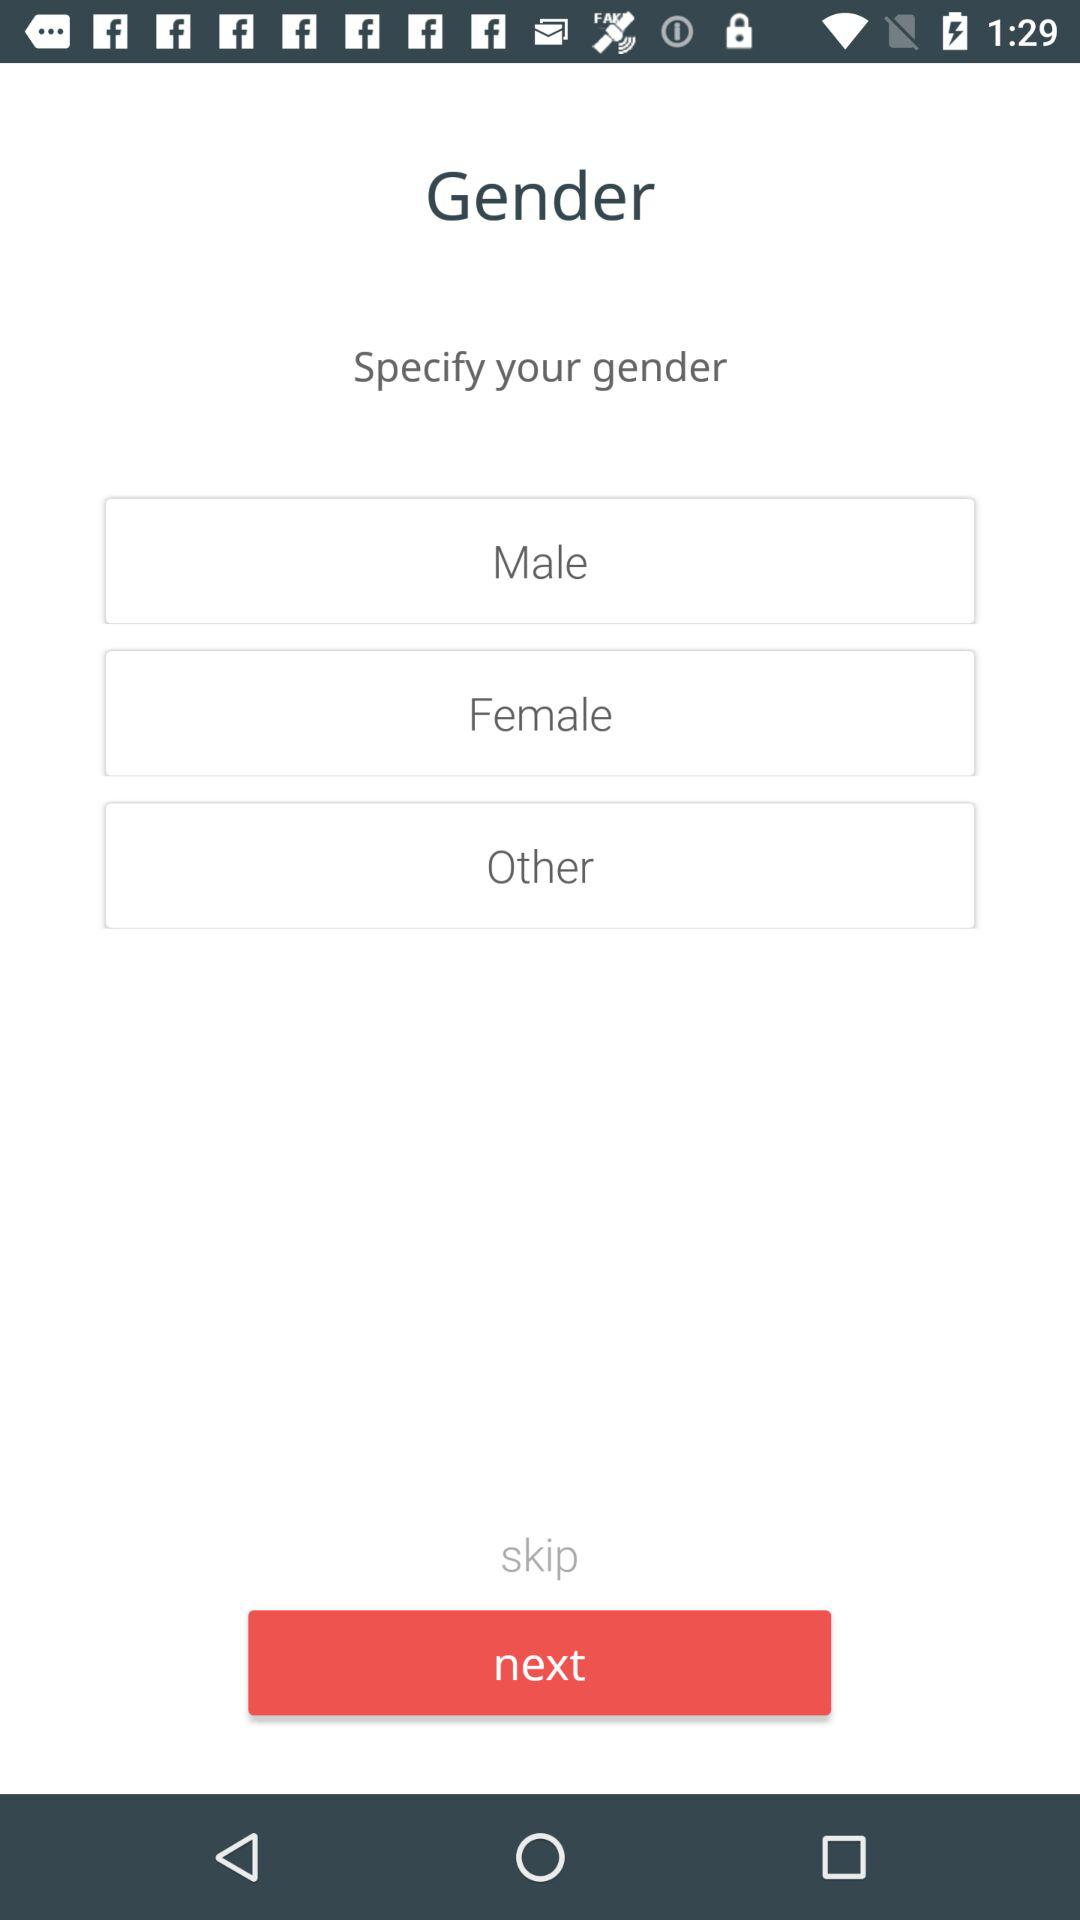Which gender is selected?
When the provided information is insufficient, respond with <no answer>. <no answer> 